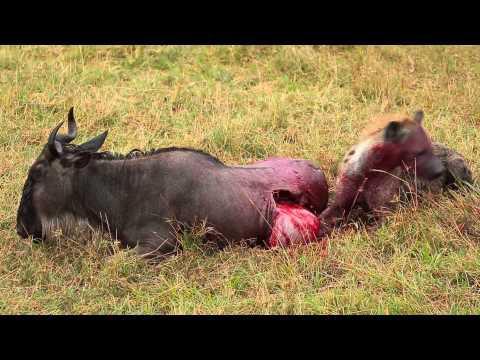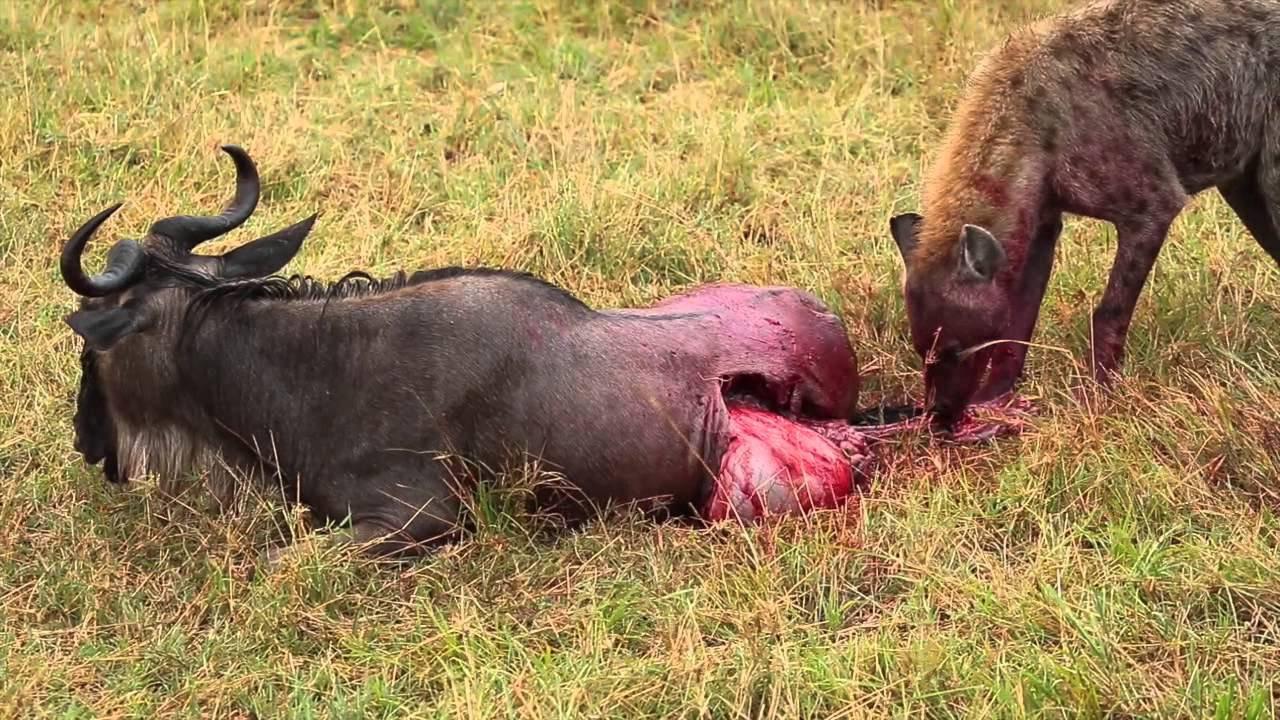The first image is the image on the left, the second image is the image on the right. For the images displayed, is the sentence "There is exactly one hyena." factually correct? Answer yes or no. No. 